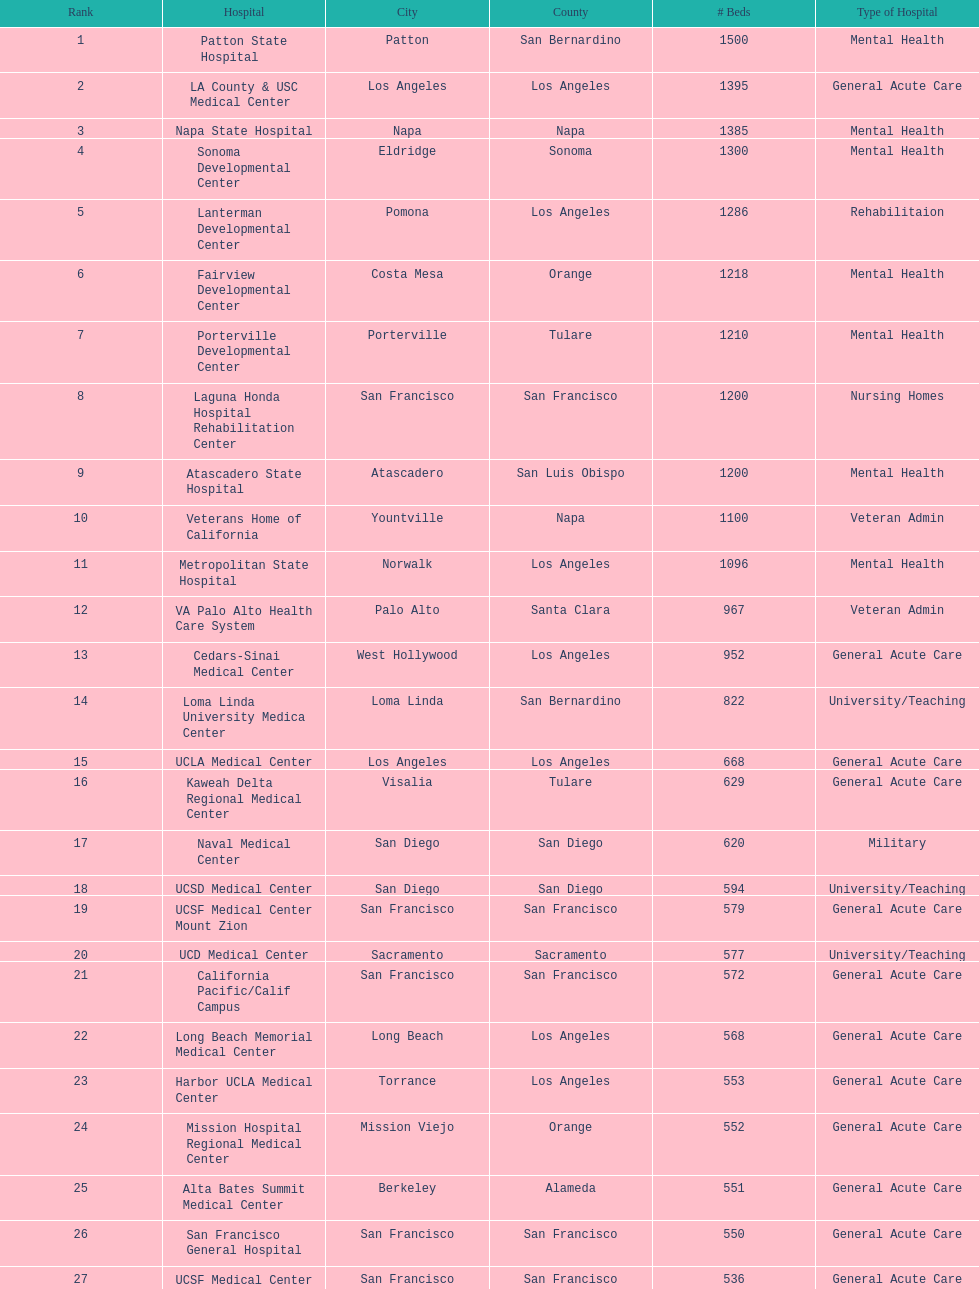How many medical centers have a minimum of 1,000 beds? 11. 